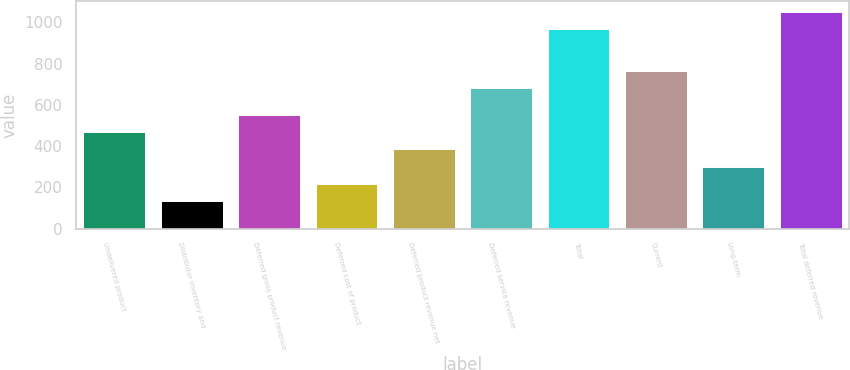Convert chart. <chart><loc_0><loc_0><loc_500><loc_500><bar_chart><fcel>Undelivered product<fcel>Distributor inventory and<fcel>Deferred gross product revenue<fcel>Deferred cost of product<fcel>Deferred product revenue net<fcel>Deferred service revenue<fcel>Total<fcel>Current<fcel>Long-term<fcel>Total deferred revenue<nl><fcel>467.2<fcel>134<fcel>550.5<fcel>217.3<fcel>383.9<fcel>681.8<fcel>967<fcel>765.1<fcel>300.6<fcel>1050.3<nl></chart> 